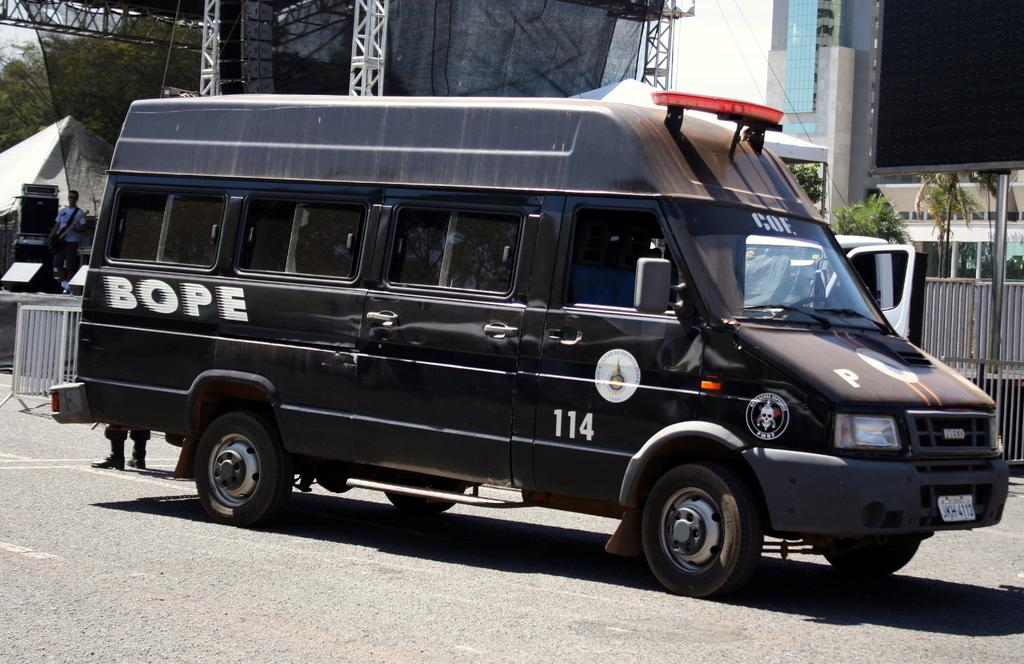Provide a one-sentence caption for the provided image. BOPE Van #114 sits parked on the street. 